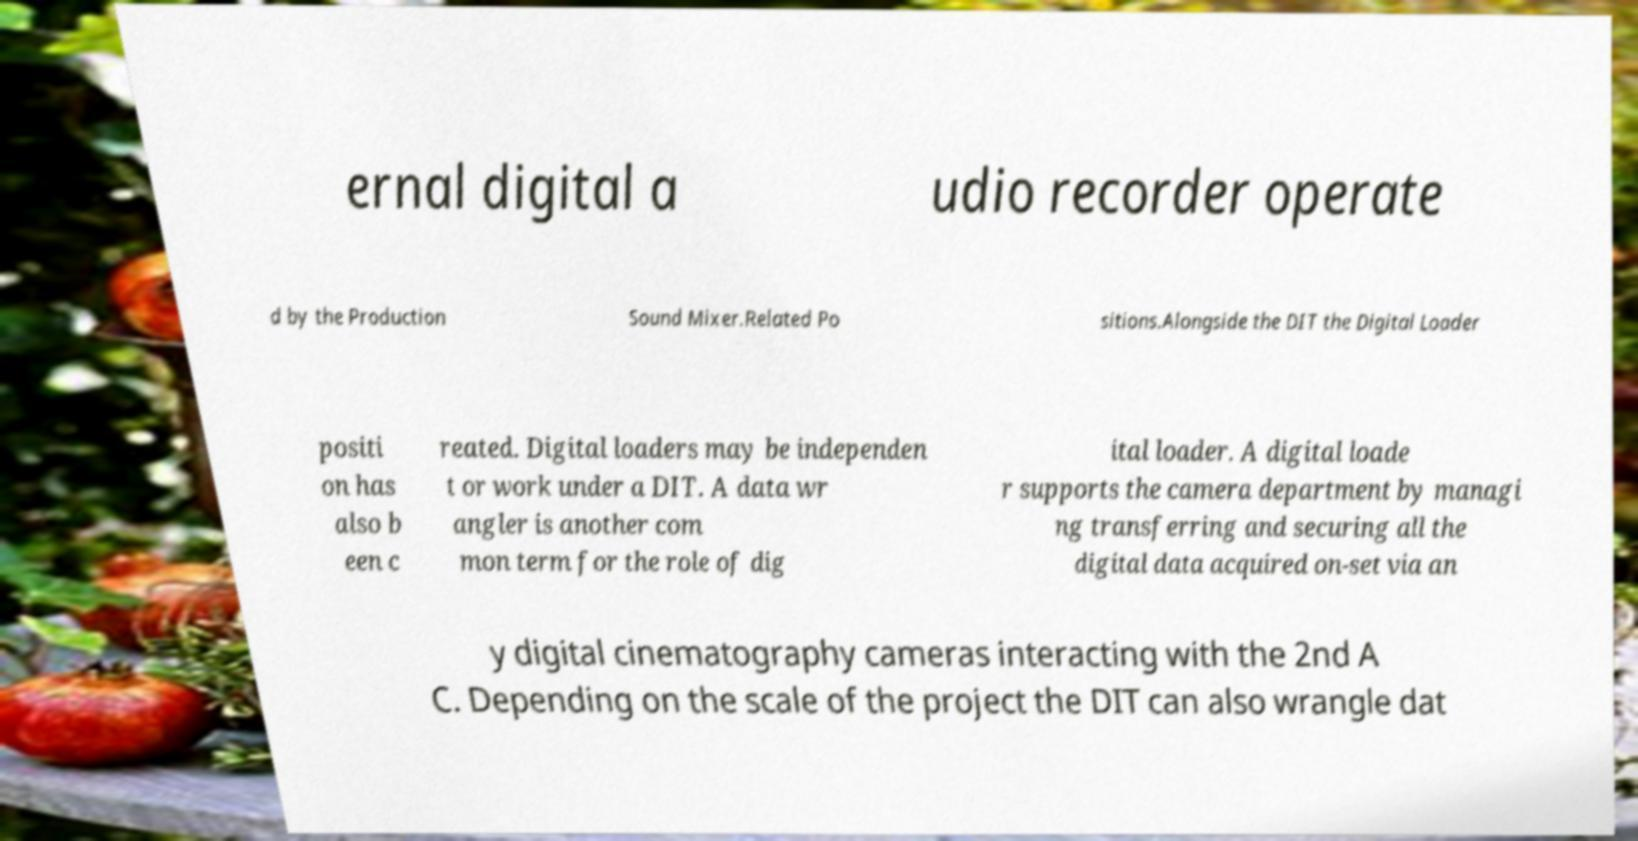Could you extract and type out the text from this image? ernal digital a udio recorder operate d by the Production Sound Mixer.Related Po sitions.Alongside the DIT the Digital Loader positi on has also b een c reated. Digital loaders may be independen t or work under a DIT. A data wr angler is another com mon term for the role of dig ital loader. A digital loade r supports the camera department by managi ng transferring and securing all the digital data acquired on-set via an y digital cinematography cameras interacting with the 2nd A C. Depending on the scale of the project the DIT can also wrangle dat 